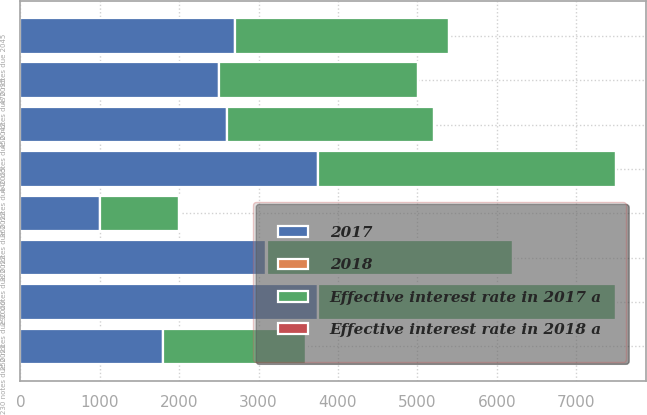Convert chart to OTSL. <chart><loc_0><loc_0><loc_500><loc_500><stacked_bar_chart><ecel><fcel>290 notes due 2022<fcel>440 notes due 2042<fcel>250 notes due 2020<fcel>320 notes due 2022<fcel>360 notes due 2025<fcel>450 notes due 2035<fcel>470 notes due 2045<fcel>230 notes due 2021<nl><fcel>Effective interest rate in 2018 a<fcel>2.97<fcel>4.46<fcel>2.65<fcel>3.28<fcel>3.66<fcel>4.58<fcel>4.73<fcel>2.4<nl><fcel>Effective interest rate in 2017 a<fcel>3100<fcel>2600<fcel>3750<fcel>1000<fcel>3750<fcel>2500<fcel>2700<fcel>1800<nl><fcel>2018<fcel>2.97<fcel>4.46<fcel>2.65<fcel>3.28<fcel>3.66<fcel>4.58<fcel>4.73<fcel>2.4<nl><fcel>2017<fcel>3100<fcel>2600<fcel>3750<fcel>1000<fcel>3750<fcel>2500<fcel>2700<fcel>1800<nl></chart> 